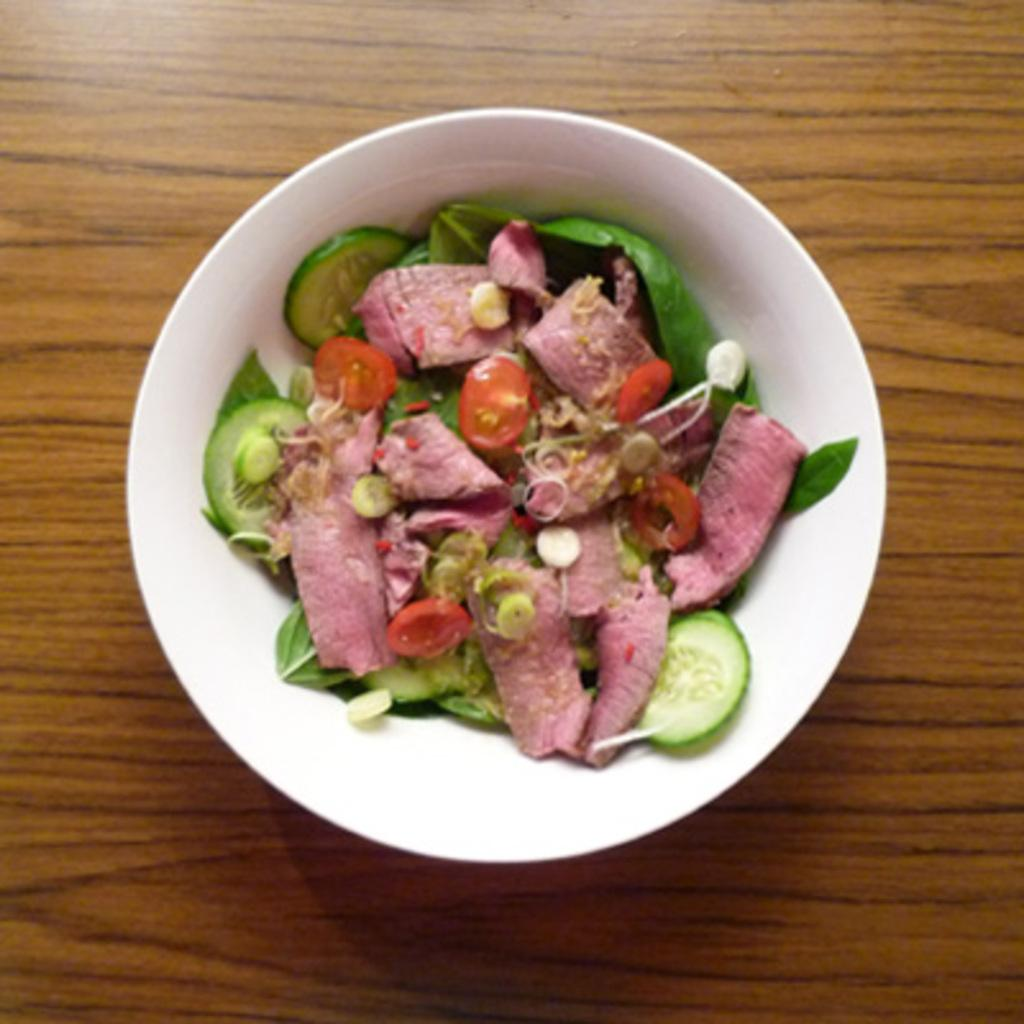What is in the bowl that is visible in the image? There is a bowl with food in the image. What type of surface is the bowl placed on? The wooden surface is present in the image. How many apples can be seen on the wooden surface in the image? There is no apple present in the image; it only shows a bowl with food on a wooden surface. 